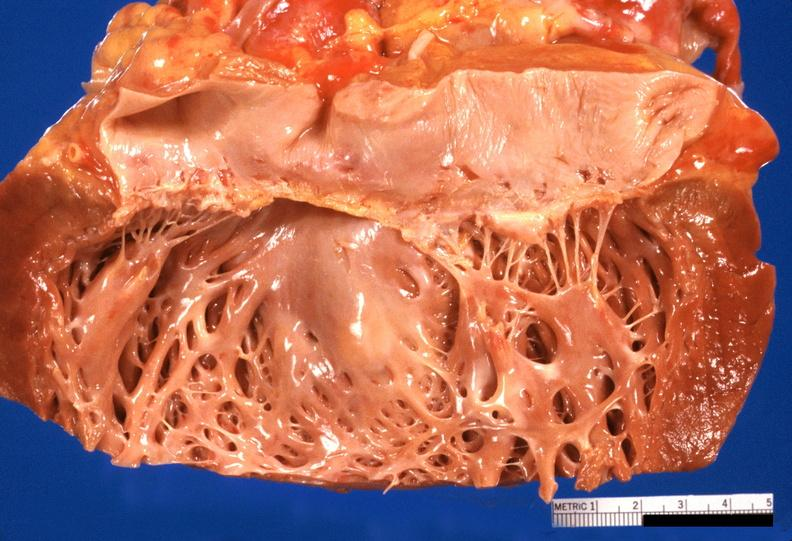does this image show heart?
Answer the question using a single word or phrase. Yes 